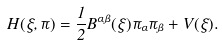<formula> <loc_0><loc_0><loc_500><loc_500>H ( \xi , \pi ) = \frac { 1 } { 2 } B ^ { \alpha \beta } ( \xi ) \pi _ { \alpha } \pi _ { \beta } + V ( \xi ) .</formula> 